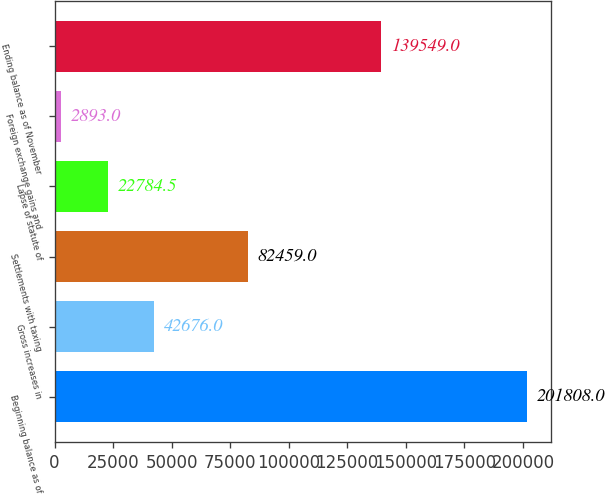<chart> <loc_0><loc_0><loc_500><loc_500><bar_chart><fcel>Beginning balance as of<fcel>Gross increases in<fcel>Settlements with taxing<fcel>Lapse of statute of<fcel>Foreign exchange gains and<fcel>Ending balance as of November<nl><fcel>201808<fcel>42676<fcel>82459<fcel>22784.5<fcel>2893<fcel>139549<nl></chart> 